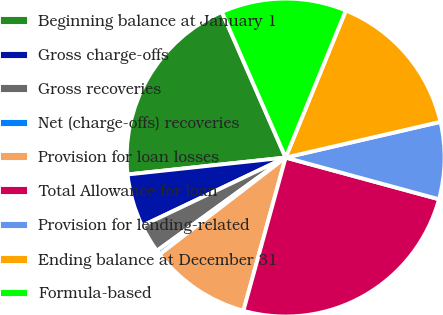Convert chart. <chart><loc_0><loc_0><loc_500><loc_500><pie_chart><fcel>Beginning balance at January 1<fcel>Gross charge-offs<fcel>Gross recoveries<fcel>Net (charge-offs) recoveries<fcel>Provision for loan losses<fcel>Total Allowance for loan<fcel>Provision for lending-related<fcel>Ending balance at December 31<fcel>Formula-based<nl><fcel>20.13%<fcel>5.37%<fcel>2.91%<fcel>0.45%<fcel>10.29%<fcel>25.05%<fcel>7.83%<fcel>15.21%<fcel>12.75%<nl></chart> 